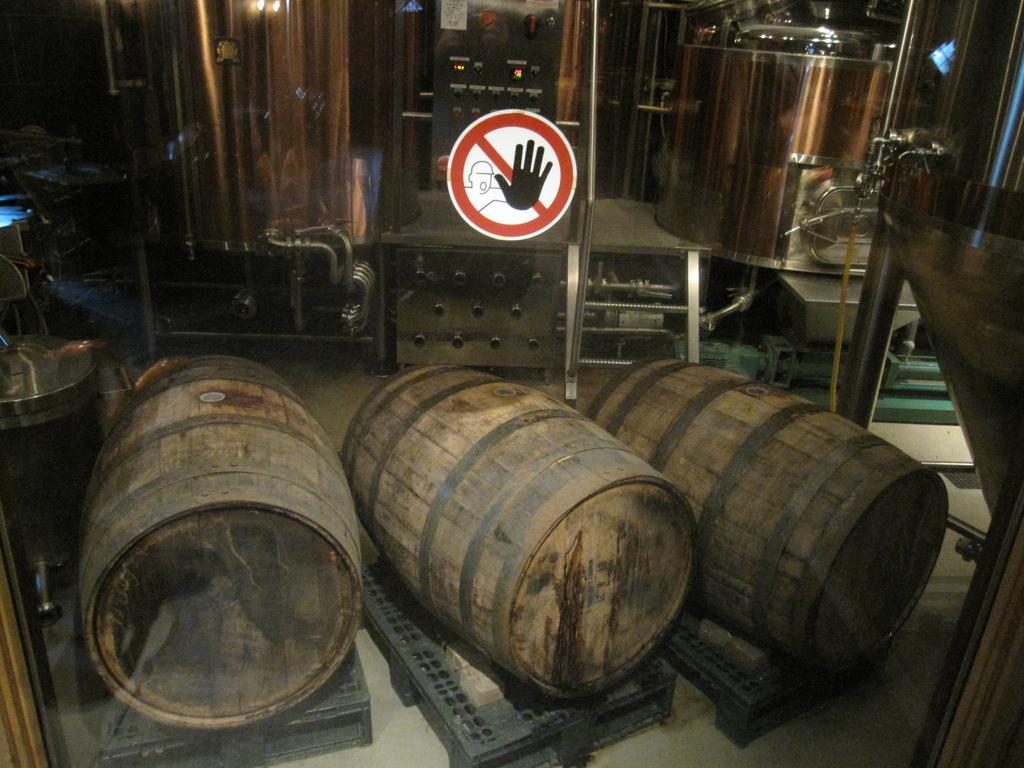What is attached to the glass in the image? There is a sign sticker on the glass. What type of equipment can be seen in the image? There are machines in the image. How many barrels are present in the image? There are three barrels in the image. What type of window treatment is visible in the image? There is a curtain in the image. What can be found on the surface in the image? There are various objects on the surface in the image. What type of oatmeal is being prepared in the image? There is no oatmeal present in the image. What mathematical operation is being performed on the barrels in the image? There is no addition or any other mathematical operation being performed on the barrels in the image. 